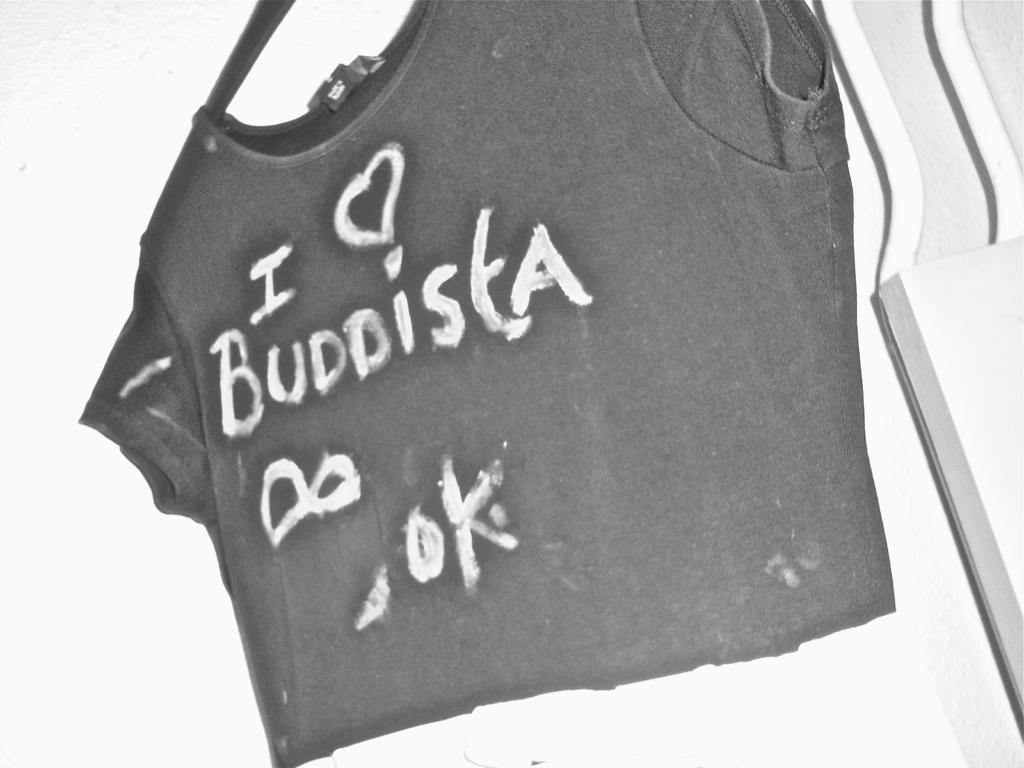How would you summarize this image in a sentence or two? In this image there is a T shirt on the hanger and there is some text on the T shirt. 